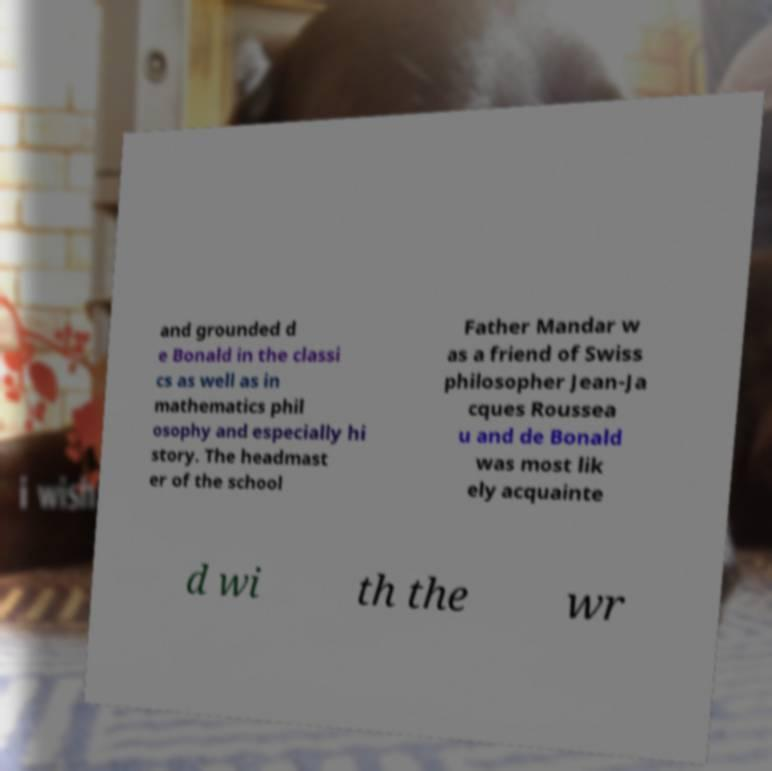Please read and relay the text visible in this image. What does it say? and grounded d e Bonald in the classi cs as well as in mathematics phil osophy and especially hi story. The headmast er of the school Father Mandar w as a friend of Swiss philosopher Jean-Ja cques Roussea u and de Bonald was most lik ely acquainte d wi th the wr 